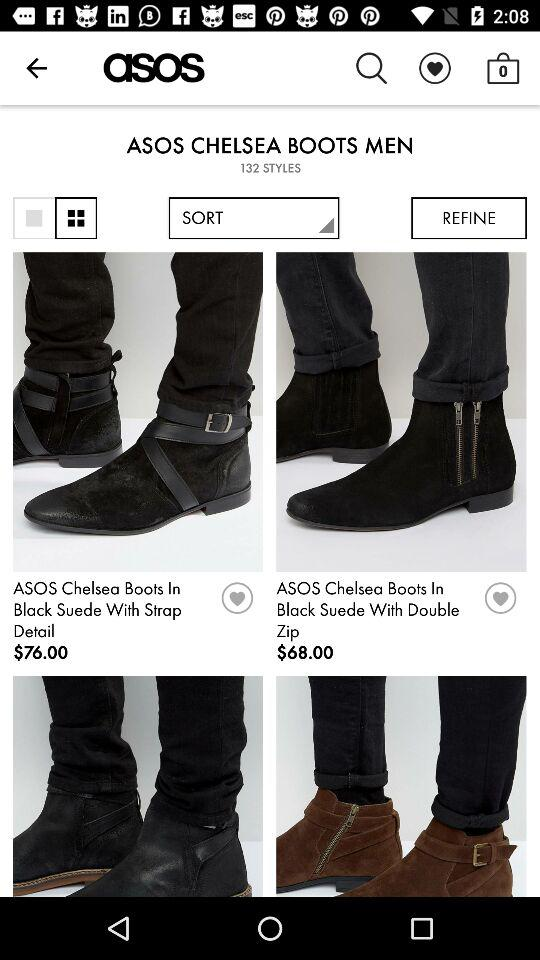What is the price of "ASOS Chelsea Boots In Black Suede With Double Zip"? The price of "ASOS Chelsea Boots In Black Suede With Double Zip" is $68. 